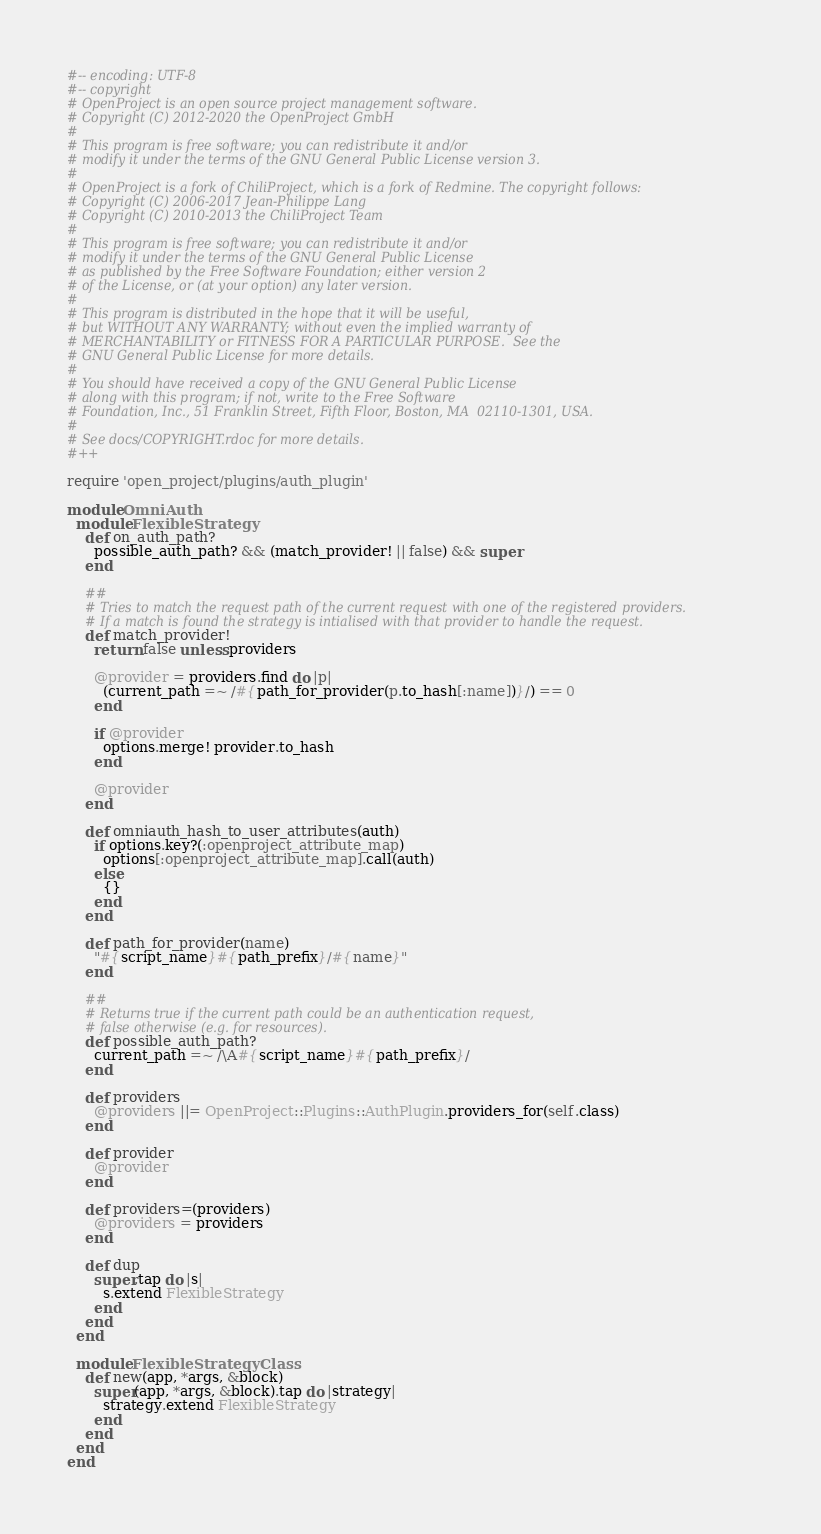Convert code to text. <code><loc_0><loc_0><loc_500><loc_500><_Ruby_>#-- encoding: UTF-8
#-- copyright
# OpenProject is an open source project management software.
# Copyright (C) 2012-2020 the OpenProject GmbH
#
# This program is free software; you can redistribute it and/or
# modify it under the terms of the GNU General Public License version 3.
#
# OpenProject is a fork of ChiliProject, which is a fork of Redmine. The copyright follows:
# Copyright (C) 2006-2017 Jean-Philippe Lang
# Copyright (C) 2010-2013 the ChiliProject Team
#
# This program is free software; you can redistribute it and/or
# modify it under the terms of the GNU General Public License
# as published by the Free Software Foundation; either version 2
# of the License, or (at your option) any later version.
#
# This program is distributed in the hope that it will be useful,
# but WITHOUT ANY WARRANTY; without even the implied warranty of
# MERCHANTABILITY or FITNESS FOR A PARTICULAR PURPOSE.  See the
# GNU General Public License for more details.
#
# You should have received a copy of the GNU General Public License
# along with this program; if not, write to the Free Software
# Foundation, Inc., 51 Franklin Street, Fifth Floor, Boston, MA  02110-1301, USA.
#
# See docs/COPYRIGHT.rdoc for more details.
#++

require 'open_project/plugins/auth_plugin'

module OmniAuth
  module FlexibleStrategy
    def on_auth_path?
      possible_auth_path? && (match_provider! || false) && super
    end

    ##
    # Tries to match the request path of the current request with one of the registered providers.
    # If a match is found the strategy is intialised with that provider to handle the request.
    def match_provider!
      return false unless providers

      @provider = providers.find do |p|
        (current_path =~ /#{path_for_provider(p.to_hash[:name])}/) == 0
      end

      if @provider
        options.merge! provider.to_hash
      end

      @provider
    end

    def omniauth_hash_to_user_attributes(auth)
      if options.key?(:openproject_attribute_map)
        options[:openproject_attribute_map].call(auth)
      else
        {}
      end
    end

    def path_for_provider(name)
      "#{script_name}#{path_prefix}/#{name}"
    end

    ##
    # Returns true if the current path could be an authentication request,
    # false otherwise (e.g. for resources).
    def possible_auth_path?
      current_path =~ /\A#{script_name}#{path_prefix}/
    end

    def providers
      @providers ||= OpenProject::Plugins::AuthPlugin.providers_for(self.class)
    end

    def provider
      @provider
    end

    def providers=(providers)
      @providers = providers
    end

    def dup
      super.tap do |s|
        s.extend FlexibleStrategy
      end
    end
  end

  module FlexibleStrategyClass
    def new(app, *args, &block)
      super(app, *args, &block).tap do |strategy|
        strategy.extend FlexibleStrategy
      end
    end
  end
end
</code> 